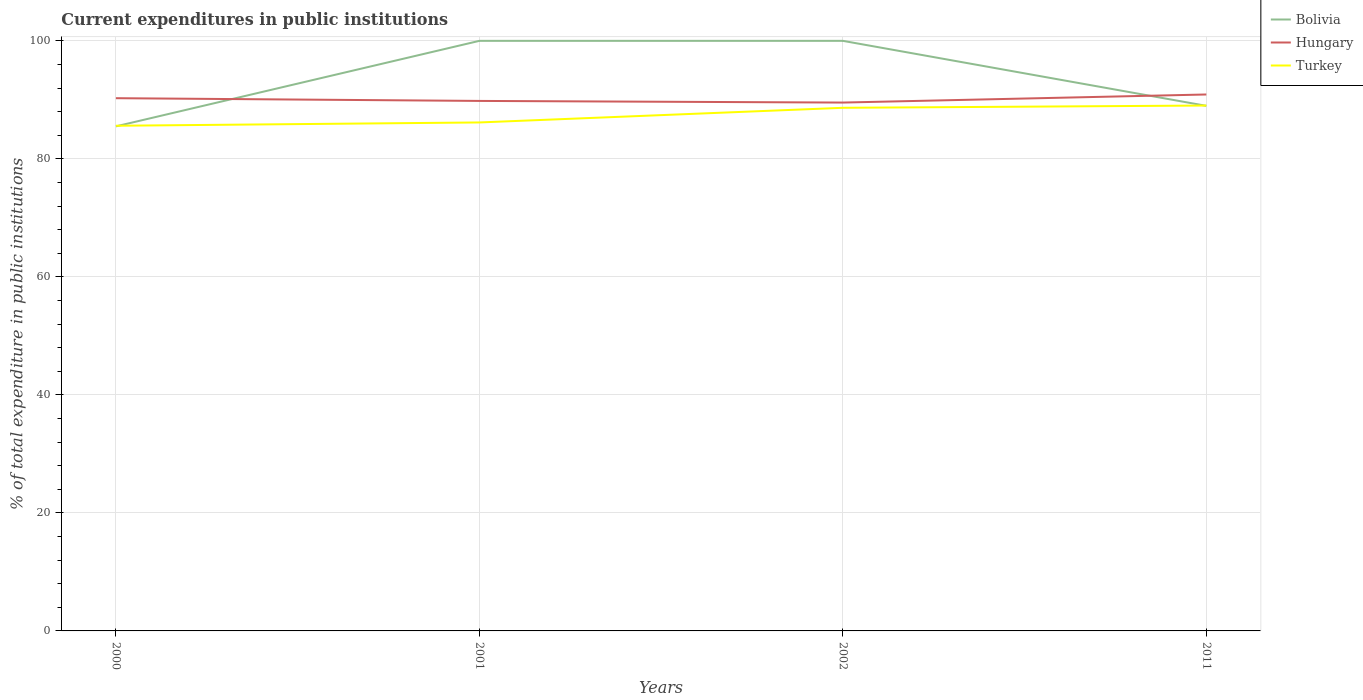Does the line corresponding to Turkey intersect with the line corresponding to Bolivia?
Give a very brief answer. Yes. Across all years, what is the maximum current expenditures in public institutions in Turkey?
Make the answer very short. 85.61. In which year was the current expenditures in public institutions in Turkey maximum?
Provide a succinct answer. 2000. What is the total current expenditures in public institutions in Turkey in the graph?
Keep it short and to the point. -0.38. What is the difference between the highest and the second highest current expenditures in public institutions in Hungary?
Give a very brief answer. 1.37. How many lines are there?
Your answer should be very brief. 3. How many years are there in the graph?
Give a very brief answer. 4. What is the difference between two consecutive major ticks on the Y-axis?
Provide a short and direct response. 20. Does the graph contain grids?
Make the answer very short. Yes. Where does the legend appear in the graph?
Your response must be concise. Top right. How many legend labels are there?
Offer a terse response. 3. How are the legend labels stacked?
Your response must be concise. Vertical. What is the title of the graph?
Provide a short and direct response. Current expenditures in public institutions. What is the label or title of the Y-axis?
Provide a succinct answer. % of total expenditure in public institutions. What is the % of total expenditure in public institutions in Bolivia in 2000?
Offer a terse response. 85.51. What is the % of total expenditure in public institutions in Hungary in 2000?
Offer a terse response. 90.28. What is the % of total expenditure in public institutions in Turkey in 2000?
Your response must be concise. 85.61. What is the % of total expenditure in public institutions of Bolivia in 2001?
Provide a short and direct response. 100. What is the % of total expenditure in public institutions in Hungary in 2001?
Provide a succinct answer. 89.82. What is the % of total expenditure in public institutions of Turkey in 2001?
Offer a terse response. 86.17. What is the % of total expenditure in public institutions of Bolivia in 2002?
Your answer should be very brief. 100. What is the % of total expenditure in public institutions in Hungary in 2002?
Offer a very short reply. 89.54. What is the % of total expenditure in public institutions of Turkey in 2002?
Provide a short and direct response. 88.66. What is the % of total expenditure in public institutions in Bolivia in 2011?
Your answer should be very brief. 88.98. What is the % of total expenditure in public institutions in Hungary in 2011?
Offer a very short reply. 90.91. What is the % of total expenditure in public institutions in Turkey in 2011?
Offer a very short reply. 89.04. Across all years, what is the maximum % of total expenditure in public institutions in Bolivia?
Your answer should be very brief. 100. Across all years, what is the maximum % of total expenditure in public institutions in Hungary?
Keep it short and to the point. 90.91. Across all years, what is the maximum % of total expenditure in public institutions in Turkey?
Keep it short and to the point. 89.04. Across all years, what is the minimum % of total expenditure in public institutions of Bolivia?
Your answer should be compact. 85.51. Across all years, what is the minimum % of total expenditure in public institutions of Hungary?
Keep it short and to the point. 89.54. Across all years, what is the minimum % of total expenditure in public institutions of Turkey?
Give a very brief answer. 85.61. What is the total % of total expenditure in public institutions of Bolivia in the graph?
Provide a short and direct response. 374.49. What is the total % of total expenditure in public institutions of Hungary in the graph?
Offer a very short reply. 360.55. What is the total % of total expenditure in public institutions in Turkey in the graph?
Give a very brief answer. 349.48. What is the difference between the % of total expenditure in public institutions in Bolivia in 2000 and that in 2001?
Ensure brevity in your answer.  -14.49. What is the difference between the % of total expenditure in public institutions of Hungary in 2000 and that in 2001?
Give a very brief answer. 0.46. What is the difference between the % of total expenditure in public institutions in Turkey in 2000 and that in 2001?
Give a very brief answer. -0.56. What is the difference between the % of total expenditure in public institutions in Bolivia in 2000 and that in 2002?
Your answer should be very brief. -14.49. What is the difference between the % of total expenditure in public institutions of Hungary in 2000 and that in 2002?
Your response must be concise. 0.74. What is the difference between the % of total expenditure in public institutions of Turkey in 2000 and that in 2002?
Provide a short and direct response. -3.04. What is the difference between the % of total expenditure in public institutions of Bolivia in 2000 and that in 2011?
Keep it short and to the point. -3.48. What is the difference between the % of total expenditure in public institutions in Hungary in 2000 and that in 2011?
Provide a short and direct response. -0.63. What is the difference between the % of total expenditure in public institutions of Turkey in 2000 and that in 2011?
Ensure brevity in your answer.  -3.43. What is the difference between the % of total expenditure in public institutions of Bolivia in 2001 and that in 2002?
Make the answer very short. 0. What is the difference between the % of total expenditure in public institutions in Hungary in 2001 and that in 2002?
Your answer should be compact. 0.28. What is the difference between the % of total expenditure in public institutions in Turkey in 2001 and that in 2002?
Offer a terse response. -2.48. What is the difference between the % of total expenditure in public institutions in Bolivia in 2001 and that in 2011?
Your answer should be compact. 11.02. What is the difference between the % of total expenditure in public institutions in Hungary in 2001 and that in 2011?
Provide a short and direct response. -1.09. What is the difference between the % of total expenditure in public institutions of Turkey in 2001 and that in 2011?
Make the answer very short. -2.87. What is the difference between the % of total expenditure in public institutions of Bolivia in 2002 and that in 2011?
Your answer should be very brief. 11.02. What is the difference between the % of total expenditure in public institutions of Hungary in 2002 and that in 2011?
Give a very brief answer. -1.37. What is the difference between the % of total expenditure in public institutions of Turkey in 2002 and that in 2011?
Offer a very short reply. -0.38. What is the difference between the % of total expenditure in public institutions in Bolivia in 2000 and the % of total expenditure in public institutions in Hungary in 2001?
Provide a short and direct response. -4.31. What is the difference between the % of total expenditure in public institutions of Bolivia in 2000 and the % of total expenditure in public institutions of Turkey in 2001?
Provide a succinct answer. -0.66. What is the difference between the % of total expenditure in public institutions of Hungary in 2000 and the % of total expenditure in public institutions of Turkey in 2001?
Keep it short and to the point. 4.11. What is the difference between the % of total expenditure in public institutions of Bolivia in 2000 and the % of total expenditure in public institutions of Hungary in 2002?
Offer a terse response. -4.03. What is the difference between the % of total expenditure in public institutions in Bolivia in 2000 and the % of total expenditure in public institutions in Turkey in 2002?
Make the answer very short. -3.15. What is the difference between the % of total expenditure in public institutions of Hungary in 2000 and the % of total expenditure in public institutions of Turkey in 2002?
Provide a short and direct response. 1.63. What is the difference between the % of total expenditure in public institutions of Bolivia in 2000 and the % of total expenditure in public institutions of Hungary in 2011?
Your response must be concise. -5.4. What is the difference between the % of total expenditure in public institutions in Bolivia in 2000 and the % of total expenditure in public institutions in Turkey in 2011?
Provide a short and direct response. -3.53. What is the difference between the % of total expenditure in public institutions of Hungary in 2000 and the % of total expenditure in public institutions of Turkey in 2011?
Offer a terse response. 1.24. What is the difference between the % of total expenditure in public institutions in Bolivia in 2001 and the % of total expenditure in public institutions in Hungary in 2002?
Your response must be concise. 10.46. What is the difference between the % of total expenditure in public institutions of Bolivia in 2001 and the % of total expenditure in public institutions of Turkey in 2002?
Provide a short and direct response. 11.34. What is the difference between the % of total expenditure in public institutions of Hungary in 2001 and the % of total expenditure in public institutions of Turkey in 2002?
Keep it short and to the point. 1.16. What is the difference between the % of total expenditure in public institutions of Bolivia in 2001 and the % of total expenditure in public institutions of Hungary in 2011?
Your response must be concise. 9.09. What is the difference between the % of total expenditure in public institutions of Bolivia in 2001 and the % of total expenditure in public institutions of Turkey in 2011?
Your answer should be very brief. 10.96. What is the difference between the % of total expenditure in public institutions in Hungary in 2001 and the % of total expenditure in public institutions in Turkey in 2011?
Offer a very short reply. 0.78. What is the difference between the % of total expenditure in public institutions in Bolivia in 2002 and the % of total expenditure in public institutions in Hungary in 2011?
Your response must be concise. 9.09. What is the difference between the % of total expenditure in public institutions of Bolivia in 2002 and the % of total expenditure in public institutions of Turkey in 2011?
Give a very brief answer. 10.96. What is the difference between the % of total expenditure in public institutions of Hungary in 2002 and the % of total expenditure in public institutions of Turkey in 2011?
Offer a terse response. 0.5. What is the average % of total expenditure in public institutions in Bolivia per year?
Your answer should be very brief. 93.62. What is the average % of total expenditure in public institutions of Hungary per year?
Offer a terse response. 90.14. What is the average % of total expenditure in public institutions in Turkey per year?
Your answer should be compact. 87.37. In the year 2000, what is the difference between the % of total expenditure in public institutions of Bolivia and % of total expenditure in public institutions of Hungary?
Offer a very short reply. -4.77. In the year 2000, what is the difference between the % of total expenditure in public institutions of Bolivia and % of total expenditure in public institutions of Turkey?
Offer a terse response. -0.1. In the year 2000, what is the difference between the % of total expenditure in public institutions in Hungary and % of total expenditure in public institutions in Turkey?
Give a very brief answer. 4.67. In the year 2001, what is the difference between the % of total expenditure in public institutions of Bolivia and % of total expenditure in public institutions of Hungary?
Your response must be concise. 10.18. In the year 2001, what is the difference between the % of total expenditure in public institutions in Bolivia and % of total expenditure in public institutions in Turkey?
Offer a very short reply. 13.83. In the year 2001, what is the difference between the % of total expenditure in public institutions of Hungary and % of total expenditure in public institutions of Turkey?
Your response must be concise. 3.65. In the year 2002, what is the difference between the % of total expenditure in public institutions of Bolivia and % of total expenditure in public institutions of Hungary?
Provide a short and direct response. 10.46. In the year 2002, what is the difference between the % of total expenditure in public institutions of Bolivia and % of total expenditure in public institutions of Turkey?
Offer a terse response. 11.34. In the year 2002, what is the difference between the % of total expenditure in public institutions of Hungary and % of total expenditure in public institutions of Turkey?
Provide a short and direct response. 0.89. In the year 2011, what is the difference between the % of total expenditure in public institutions of Bolivia and % of total expenditure in public institutions of Hungary?
Your answer should be compact. -1.93. In the year 2011, what is the difference between the % of total expenditure in public institutions of Bolivia and % of total expenditure in public institutions of Turkey?
Provide a succinct answer. -0.05. In the year 2011, what is the difference between the % of total expenditure in public institutions of Hungary and % of total expenditure in public institutions of Turkey?
Give a very brief answer. 1.87. What is the ratio of the % of total expenditure in public institutions in Bolivia in 2000 to that in 2001?
Your response must be concise. 0.86. What is the ratio of the % of total expenditure in public institutions of Hungary in 2000 to that in 2001?
Keep it short and to the point. 1.01. What is the ratio of the % of total expenditure in public institutions in Turkey in 2000 to that in 2001?
Your response must be concise. 0.99. What is the ratio of the % of total expenditure in public institutions in Bolivia in 2000 to that in 2002?
Provide a succinct answer. 0.86. What is the ratio of the % of total expenditure in public institutions of Hungary in 2000 to that in 2002?
Offer a terse response. 1.01. What is the ratio of the % of total expenditure in public institutions in Turkey in 2000 to that in 2002?
Your answer should be compact. 0.97. What is the ratio of the % of total expenditure in public institutions in Bolivia in 2000 to that in 2011?
Your response must be concise. 0.96. What is the ratio of the % of total expenditure in public institutions of Turkey in 2000 to that in 2011?
Offer a very short reply. 0.96. What is the ratio of the % of total expenditure in public institutions of Hungary in 2001 to that in 2002?
Your answer should be compact. 1. What is the ratio of the % of total expenditure in public institutions of Bolivia in 2001 to that in 2011?
Offer a terse response. 1.12. What is the ratio of the % of total expenditure in public institutions in Hungary in 2001 to that in 2011?
Your answer should be compact. 0.99. What is the ratio of the % of total expenditure in public institutions in Turkey in 2001 to that in 2011?
Offer a very short reply. 0.97. What is the ratio of the % of total expenditure in public institutions in Bolivia in 2002 to that in 2011?
Ensure brevity in your answer.  1.12. What is the ratio of the % of total expenditure in public institutions of Hungary in 2002 to that in 2011?
Offer a terse response. 0.98. What is the difference between the highest and the second highest % of total expenditure in public institutions in Hungary?
Offer a terse response. 0.63. What is the difference between the highest and the second highest % of total expenditure in public institutions in Turkey?
Your answer should be very brief. 0.38. What is the difference between the highest and the lowest % of total expenditure in public institutions in Bolivia?
Your answer should be compact. 14.49. What is the difference between the highest and the lowest % of total expenditure in public institutions of Hungary?
Your answer should be compact. 1.37. What is the difference between the highest and the lowest % of total expenditure in public institutions in Turkey?
Your answer should be compact. 3.43. 